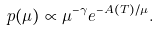Convert formula to latex. <formula><loc_0><loc_0><loc_500><loc_500>p ( \mu ) \varpropto \mu ^ { - \gamma } e ^ { - A ( T ) / \mu } .</formula> 